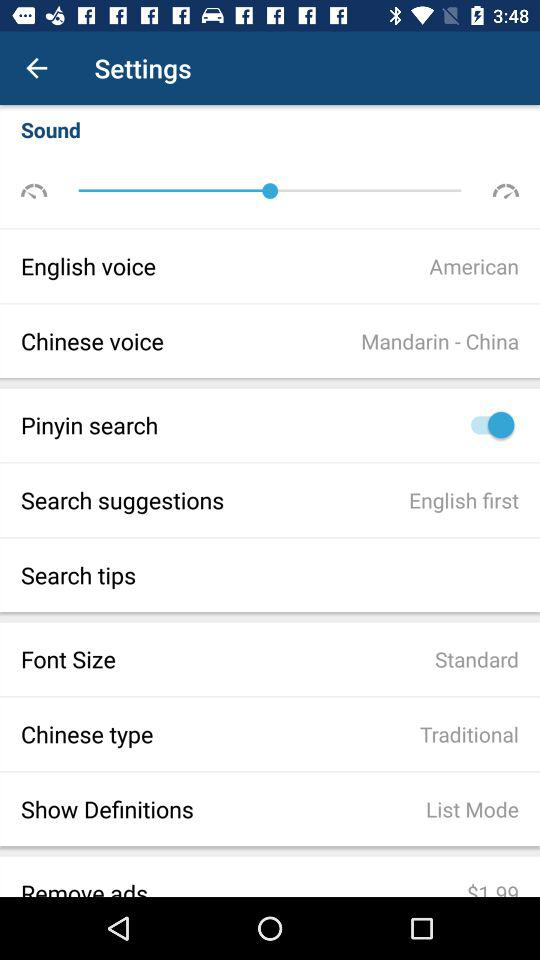What is the type of "Chinese voice"? The type of "Chinese voice" is "Mandarin - China". 